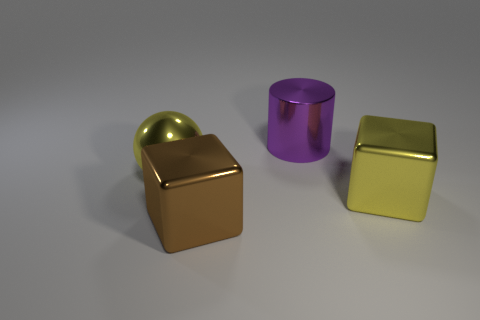Add 4 big purple cylinders. How many objects exist? 8 Subtract all balls. How many objects are left? 3 Subtract all tiny gray metal things. Subtract all big yellow metallic balls. How many objects are left? 3 Add 2 big metallic blocks. How many big metallic blocks are left? 4 Add 2 tiny blue metal objects. How many tiny blue metal objects exist? 2 Subtract 0 gray spheres. How many objects are left? 4 